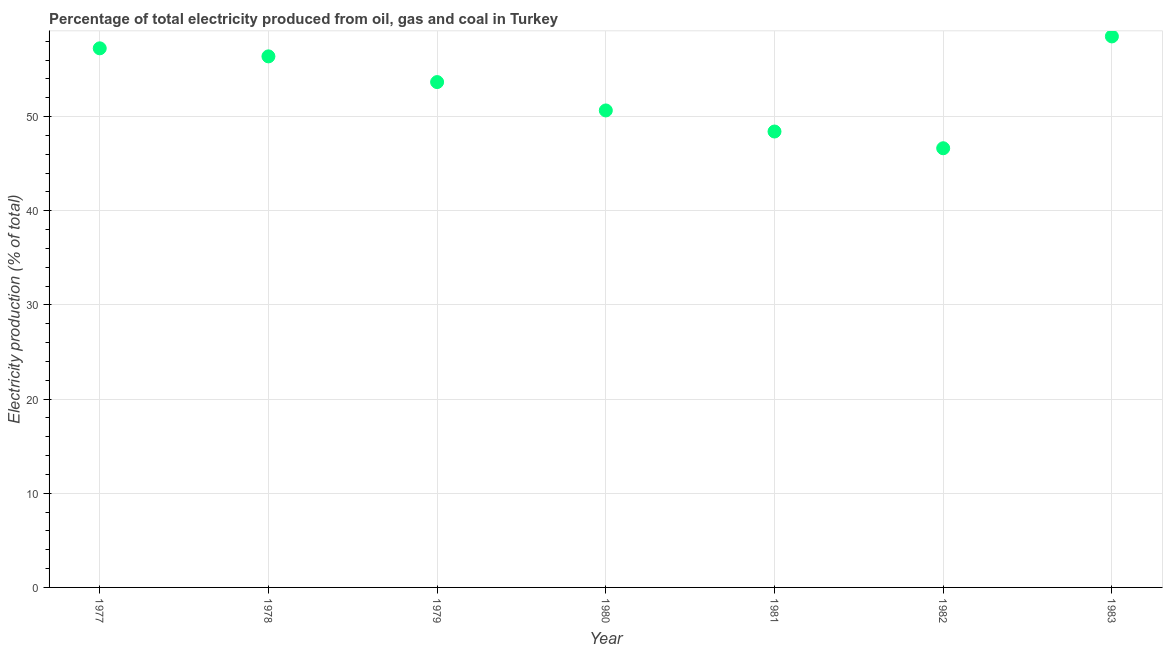What is the electricity production in 1980?
Make the answer very short. 50.66. Across all years, what is the maximum electricity production?
Offer a very short reply. 58.52. Across all years, what is the minimum electricity production?
Make the answer very short. 46.64. In which year was the electricity production maximum?
Make the answer very short. 1983. In which year was the electricity production minimum?
Keep it short and to the point. 1982. What is the sum of the electricity production?
Offer a very short reply. 371.58. What is the difference between the electricity production in 1978 and 1983?
Keep it short and to the point. -2.12. What is the average electricity production per year?
Offer a terse response. 53.08. What is the median electricity production?
Provide a succinct answer. 53.67. Do a majority of the years between 1982 and 1981 (inclusive) have electricity production greater than 46 %?
Your answer should be very brief. No. What is the ratio of the electricity production in 1977 to that in 1981?
Your answer should be very brief. 1.18. Is the electricity production in 1978 less than that in 1980?
Your answer should be compact. No. Is the difference between the electricity production in 1977 and 1979 greater than the difference between any two years?
Offer a terse response. No. What is the difference between the highest and the second highest electricity production?
Give a very brief answer. 1.26. What is the difference between the highest and the lowest electricity production?
Offer a terse response. 11.88. In how many years, is the electricity production greater than the average electricity production taken over all years?
Make the answer very short. 4. Does the electricity production monotonically increase over the years?
Your answer should be compact. No. What is the difference between two consecutive major ticks on the Y-axis?
Your response must be concise. 10. Does the graph contain any zero values?
Give a very brief answer. No. Does the graph contain grids?
Keep it short and to the point. Yes. What is the title of the graph?
Your answer should be very brief. Percentage of total electricity produced from oil, gas and coal in Turkey. What is the label or title of the X-axis?
Ensure brevity in your answer.  Year. What is the label or title of the Y-axis?
Make the answer very short. Electricity production (% of total). What is the Electricity production (% of total) in 1977?
Your answer should be very brief. 57.26. What is the Electricity production (% of total) in 1978?
Provide a succinct answer. 56.4. What is the Electricity production (% of total) in 1979?
Your answer should be very brief. 53.67. What is the Electricity production (% of total) in 1980?
Offer a very short reply. 50.66. What is the Electricity production (% of total) in 1981?
Provide a succinct answer. 48.42. What is the Electricity production (% of total) in 1982?
Ensure brevity in your answer.  46.64. What is the Electricity production (% of total) in 1983?
Keep it short and to the point. 58.52. What is the difference between the Electricity production (% of total) in 1977 and 1978?
Make the answer very short. 0.86. What is the difference between the Electricity production (% of total) in 1977 and 1979?
Provide a short and direct response. 3.59. What is the difference between the Electricity production (% of total) in 1977 and 1980?
Your answer should be very brief. 6.6. What is the difference between the Electricity production (% of total) in 1977 and 1981?
Your response must be concise. 8.84. What is the difference between the Electricity production (% of total) in 1977 and 1982?
Provide a succinct answer. 10.61. What is the difference between the Electricity production (% of total) in 1977 and 1983?
Give a very brief answer. -1.26. What is the difference between the Electricity production (% of total) in 1978 and 1979?
Provide a short and direct response. 2.73. What is the difference between the Electricity production (% of total) in 1978 and 1980?
Ensure brevity in your answer.  5.74. What is the difference between the Electricity production (% of total) in 1978 and 1981?
Offer a very short reply. 7.98. What is the difference between the Electricity production (% of total) in 1978 and 1982?
Provide a short and direct response. 9.76. What is the difference between the Electricity production (% of total) in 1978 and 1983?
Provide a short and direct response. -2.12. What is the difference between the Electricity production (% of total) in 1979 and 1980?
Your answer should be very brief. 3.01. What is the difference between the Electricity production (% of total) in 1979 and 1981?
Your answer should be very brief. 5.25. What is the difference between the Electricity production (% of total) in 1979 and 1982?
Provide a short and direct response. 7.03. What is the difference between the Electricity production (% of total) in 1979 and 1983?
Make the answer very short. -4.85. What is the difference between the Electricity production (% of total) in 1980 and 1981?
Offer a very short reply. 2.24. What is the difference between the Electricity production (% of total) in 1980 and 1982?
Make the answer very short. 4.02. What is the difference between the Electricity production (% of total) in 1980 and 1983?
Your answer should be compact. -7.86. What is the difference between the Electricity production (% of total) in 1981 and 1982?
Keep it short and to the point. 1.78. What is the difference between the Electricity production (% of total) in 1981 and 1983?
Offer a very short reply. -10.1. What is the difference between the Electricity production (% of total) in 1982 and 1983?
Give a very brief answer. -11.88. What is the ratio of the Electricity production (% of total) in 1977 to that in 1978?
Make the answer very short. 1.01. What is the ratio of the Electricity production (% of total) in 1977 to that in 1979?
Give a very brief answer. 1.07. What is the ratio of the Electricity production (% of total) in 1977 to that in 1980?
Give a very brief answer. 1.13. What is the ratio of the Electricity production (% of total) in 1977 to that in 1981?
Your response must be concise. 1.18. What is the ratio of the Electricity production (% of total) in 1977 to that in 1982?
Your answer should be compact. 1.23. What is the ratio of the Electricity production (% of total) in 1977 to that in 1983?
Provide a succinct answer. 0.98. What is the ratio of the Electricity production (% of total) in 1978 to that in 1979?
Offer a terse response. 1.05. What is the ratio of the Electricity production (% of total) in 1978 to that in 1980?
Offer a terse response. 1.11. What is the ratio of the Electricity production (% of total) in 1978 to that in 1981?
Make the answer very short. 1.17. What is the ratio of the Electricity production (% of total) in 1978 to that in 1982?
Keep it short and to the point. 1.21. What is the ratio of the Electricity production (% of total) in 1979 to that in 1980?
Give a very brief answer. 1.06. What is the ratio of the Electricity production (% of total) in 1979 to that in 1981?
Keep it short and to the point. 1.11. What is the ratio of the Electricity production (% of total) in 1979 to that in 1982?
Keep it short and to the point. 1.15. What is the ratio of the Electricity production (% of total) in 1979 to that in 1983?
Your answer should be very brief. 0.92. What is the ratio of the Electricity production (% of total) in 1980 to that in 1981?
Provide a succinct answer. 1.05. What is the ratio of the Electricity production (% of total) in 1980 to that in 1982?
Provide a succinct answer. 1.09. What is the ratio of the Electricity production (% of total) in 1980 to that in 1983?
Ensure brevity in your answer.  0.87. What is the ratio of the Electricity production (% of total) in 1981 to that in 1982?
Provide a short and direct response. 1.04. What is the ratio of the Electricity production (% of total) in 1981 to that in 1983?
Make the answer very short. 0.83. What is the ratio of the Electricity production (% of total) in 1982 to that in 1983?
Offer a terse response. 0.8. 